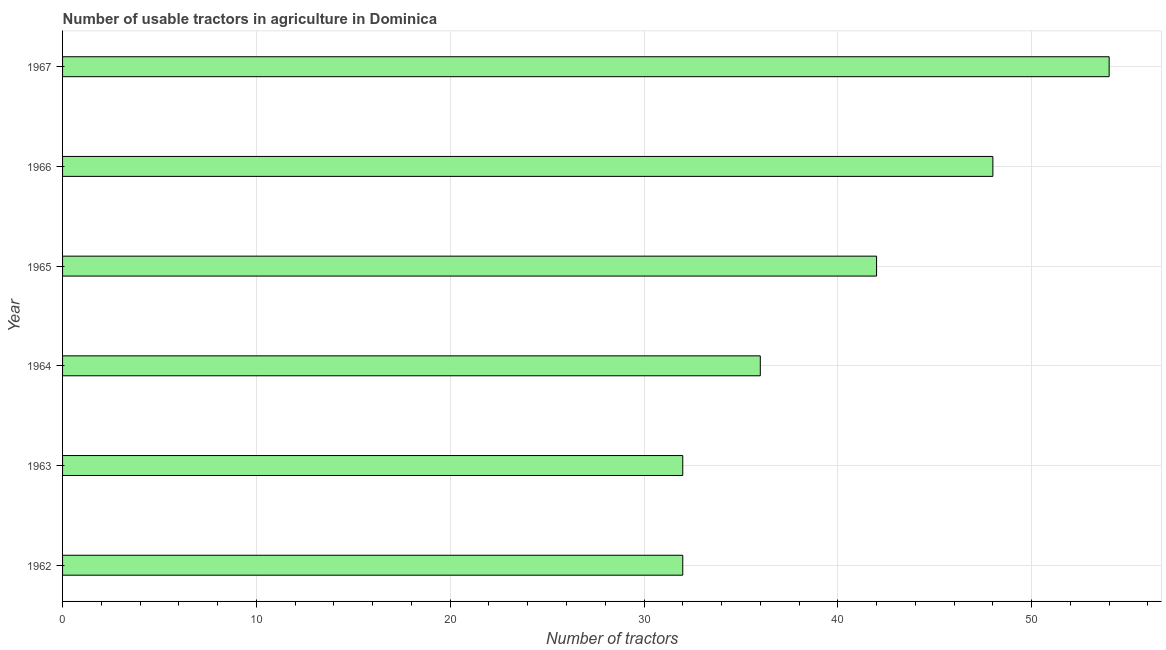Does the graph contain any zero values?
Make the answer very short. No. Does the graph contain grids?
Offer a very short reply. Yes. What is the title of the graph?
Keep it short and to the point. Number of usable tractors in agriculture in Dominica. What is the label or title of the X-axis?
Offer a terse response. Number of tractors. What is the number of tractors in 1967?
Your answer should be very brief. 54. Across all years, what is the maximum number of tractors?
Give a very brief answer. 54. In which year was the number of tractors maximum?
Ensure brevity in your answer.  1967. In which year was the number of tractors minimum?
Provide a succinct answer. 1962. What is the sum of the number of tractors?
Keep it short and to the point. 244. In how many years, is the number of tractors greater than 42 ?
Your answer should be very brief. 2. Do a majority of the years between 1966 and 1967 (inclusive) have number of tractors greater than 52 ?
Make the answer very short. No. What is the ratio of the number of tractors in 1964 to that in 1965?
Your answer should be compact. 0.86. Is the difference between the number of tractors in 1962 and 1964 greater than the difference between any two years?
Provide a short and direct response. No. How many bars are there?
Provide a short and direct response. 6. How many years are there in the graph?
Your response must be concise. 6. What is the difference between two consecutive major ticks on the X-axis?
Your answer should be compact. 10. What is the Number of tractors in 1962?
Offer a terse response. 32. What is the Number of tractors in 1965?
Offer a terse response. 42. What is the difference between the Number of tractors in 1962 and 1963?
Offer a very short reply. 0. What is the difference between the Number of tractors in 1962 and 1964?
Provide a succinct answer. -4. What is the difference between the Number of tractors in 1962 and 1965?
Provide a short and direct response. -10. What is the difference between the Number of tractors in 1962 and 1967?
Give a very brief answer. -22. What is the difference between the Number of tractors in 1963 and 1964?
Keep it short and to the point. -4. What is the difference between the Number of tractors in 1963 and 1967?
Offer a terse response. -22. What is the difference between the Number of tractors in 1964 and 1966?
Your answer should be compact. -12. What is the difference between the Number of tractors in 1964 and 1967?
Offer a terse response. -18. What is the difference between the Number of tractors in 1965 and 1966?
Provide a short and direct response. -6. What is the difference between the Number of tractors in 1965 and 1967?
Ensure brevity in your answer.  -12. What is the difference between the Number of tractors in 1966 and 1967?
Give a very brief answer. -6. What is the ratio of the Number of tractors in 1962 to that in 1964?
Ensure brevity in your answer.  0.89. What is the ratio of the Number of tractors in 1962 to that in 1965?
Give a very brief answer. 0.76. What is the ratio of the Number of tractors in 1962 to that in 1966?
Make the answer very short. 0.67. What is the ratio of the Number of tractors in 1962 to that in 1967?
Give a very brief answer. 0.59. What is the ratio of the Number of tractors in 1963 to that in 1964?
Give a very brief answer. 0.89. What is the ratio of the Number of tractors in 1963 to that in 1965?
Your answer should be very brief. 0.76. What is the ratio of the Number of tractors in 1963 to that in 1966?
Provide a short and direct response. 0.67. What is the ratio of the Number of tractors in 1963 to that in 1967?
Give a very brief answer. 0.59. What is the ratio of the Number of tractors in 1964 to that in 1965?
Your response must be concise. 0.86. What is the ratio of the Number of tractors in 1964 to that in 1967?
Your response must be concise. 0.67. What is the ratio of the Number of tractors in 1965 to that in 1966?
Your response must be concise. 0.88. What is the ratio of the Number of tractors in 1965 to that in 1967?
Offer a very short reply. 0.78. What is the ratio of the Number of tractors in 1966 to that in 1967?
Give a very brief answer. 0.89. 